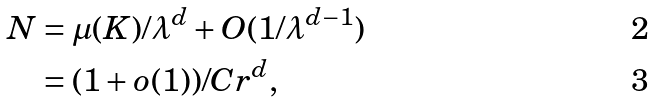<formula> <loc_0><loc_0><loc_500><loc_500>N & = \mu ( K ) / \lambda ^ { d } + O ( 1 / \lambda ^ { d - 1 } ) \\ & = ( 1 + o ( 1 ) ) / C r ^ { d } ,</formula> 